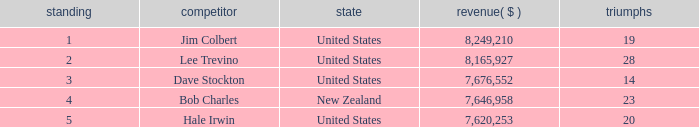How many average wins for players ranked below 2 with earnings greater than $7,676,552? None. 